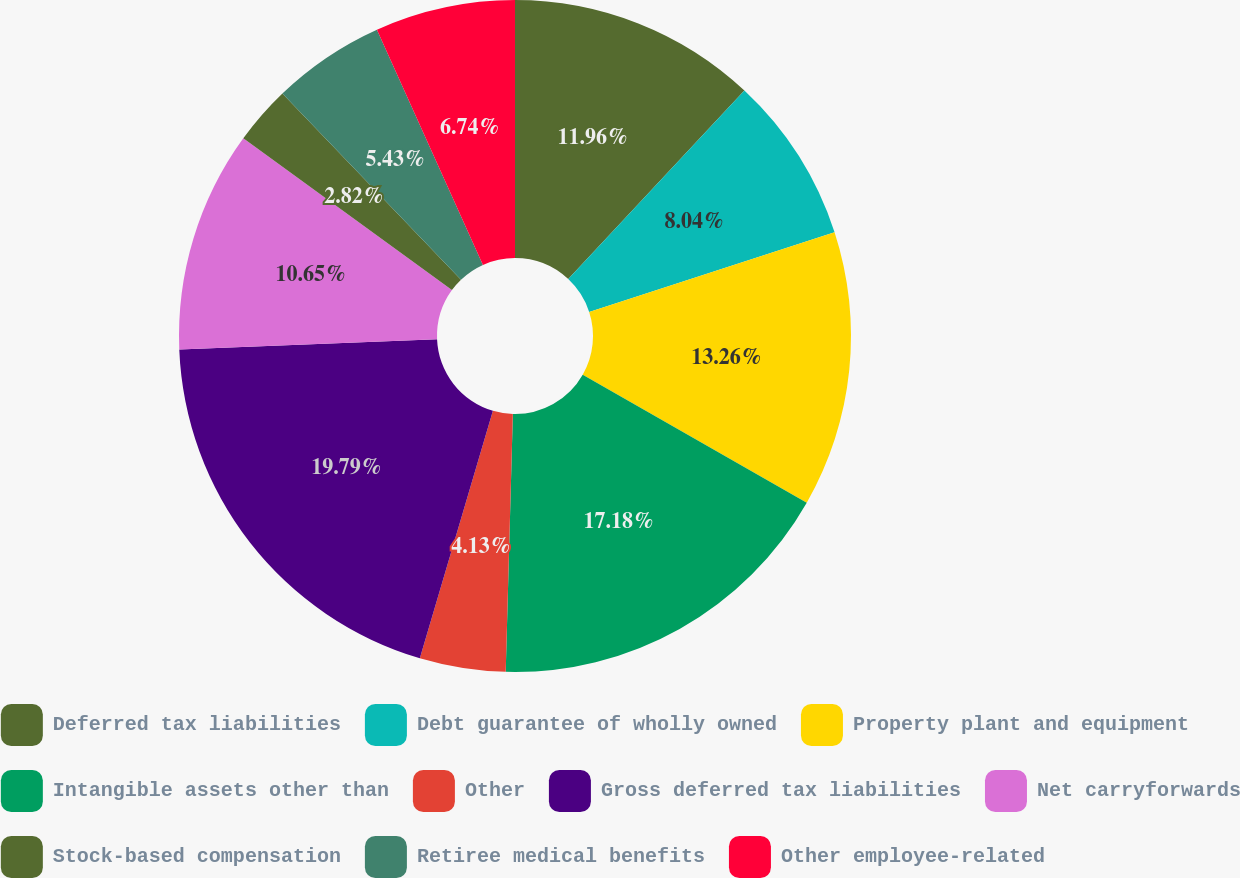<chart> <loc_0><loc_0><loc_500><loc_500><pie_chart><fcel>Deferred tax liabilities<fcel>Debt guarantee of wholly owned<fcel>Property plant and equipment<fcel>Intangible assets other than<fcel>Other<fcel>Gross deferred tax liabilities<fcel>Net carryforwards<fcel>Stock-based compensation<fcel>Retiree medical benefits<fcel>Other employee-related<nl><fcel>11.96%<fcel>8.04%<fcel>13.26%<fcel>17.18%<fcel>4.13%<fcel>19.79%<fcel>10.65%<fcel>2.82%<fcel>5.43%<fcel>6.74%<nl></chart> 